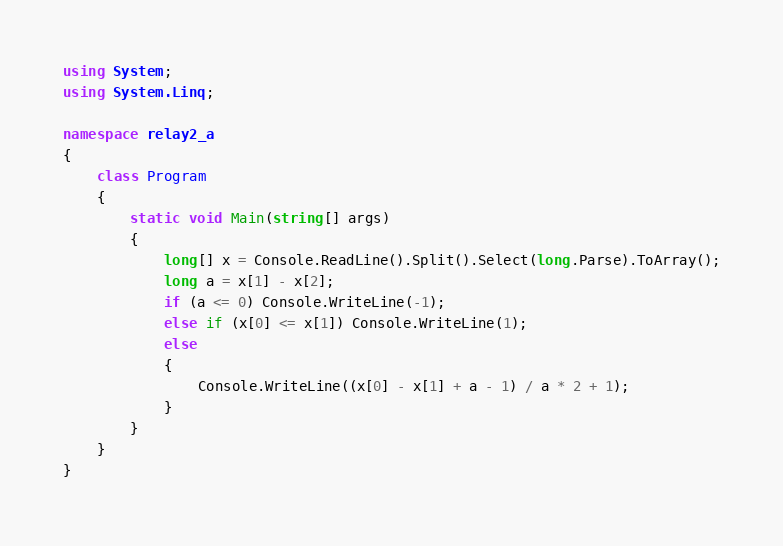Convert code to text. <code><loc_0><loc_0><loc_500><loc_500><_C#_>using System;
using System.Linq;

namespace relay2_a
{
    class Program
    {
        static void Main(string[] args)
        {
            long[] x = Console.ReadLine().Split().Select(long.Parse).ToArray();
            long a = x[1] - x[2];
            if (a <= 0) Console.WriteLine(-1);
            else if (x[0] <= x[1]) Console.WriteLine(1);
            else
            {
                Console.WriteLine((x[0] - x[1] + a - 1) / a * 2 + 1);
            }
        }
    }
}</code> 